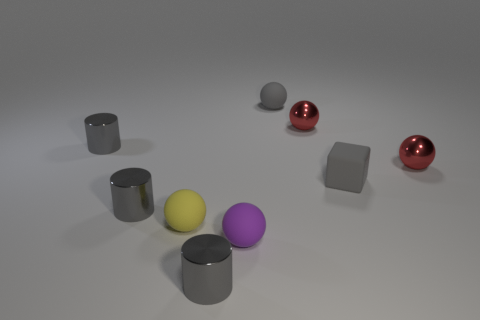What is the shape of the purple object that is made of the same material as the tiny gray ball?
Ensure brevity in your answer.  Sphere. How many tiny gray things are left of the tiny gray rubber thing that is behind the tiny gray rubber block?
Make the answer very short. 3. What number of tiny things are left of the gray rubber sphere and on the right side of the tiny gray matte cube?
Keep it short and to the point. 0. How many other things are there of the same material as the tiny gray sphere?
Offer a terse response. 3. There is a cube on the right side of the cylinder that is in front of the yellow ball; what color is it?
Give a very brief answer. Gray. There is a cylinder that is right of the tiny yellow sphere; is its color the same as the rubber block?
Give a very brief answer. Yes. Does the matte cube have the same size as the purple matte object?
Provide a succinct answer. Yes. There is a gray rubber thing that is the same size as the gray rubber ball; what is its shape?
Ensure brevity in your answer.  Cube. What is the material of the gray ball that is the same size as the purple sphere?
Make the answer very short. Rubber. Is there a red metal object that is to the right of the gray metal thing behind the gray thing that is on the right side of the tiny gray matte sphere?
Your response must be concise. Yes. 